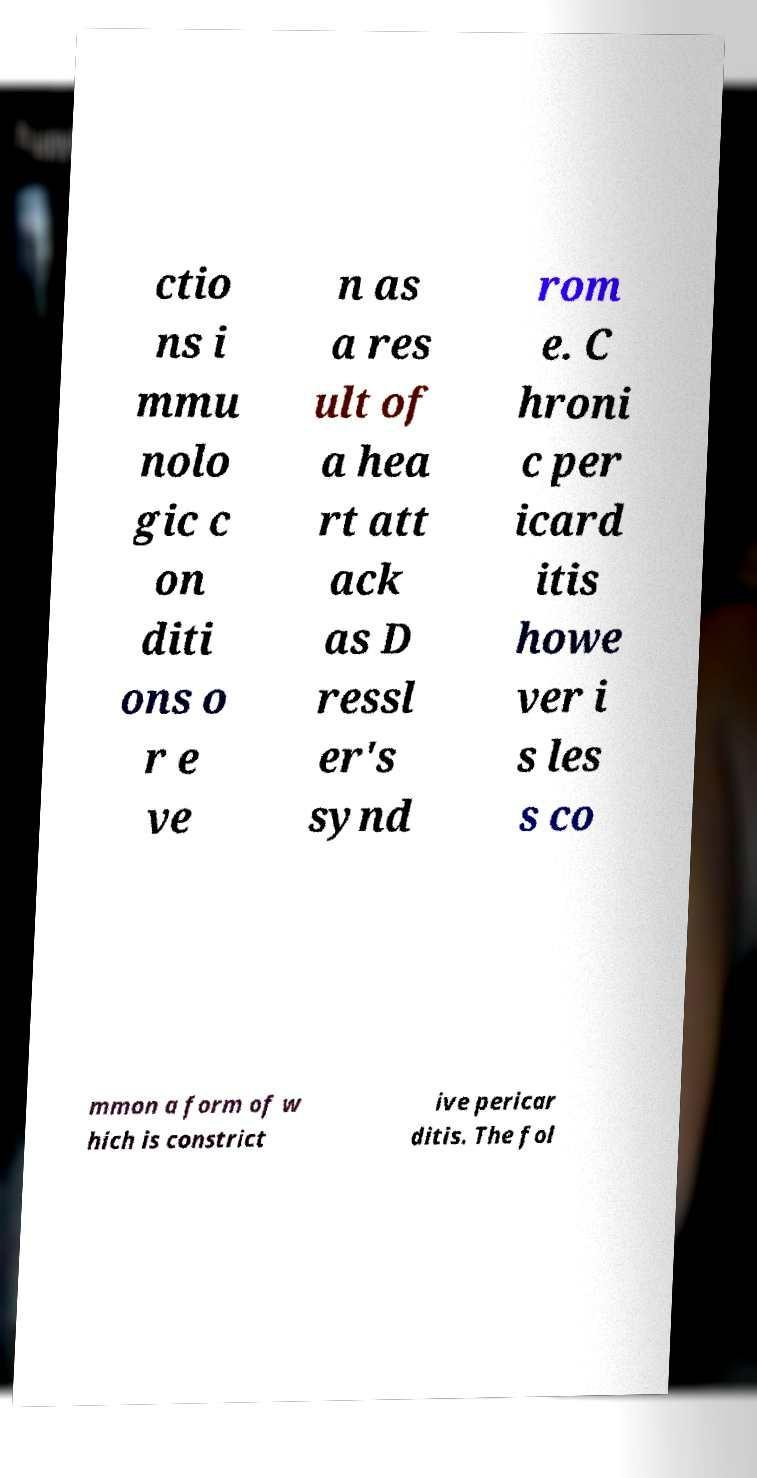Could you assist in decoding the text presented in this image and type it out clearly? ctio ns i mmu nolo gic c on diti ons o r e ve n as a res ult of a hea rt att ack as D ressl er's synd rom e. C hroni c per icard itis howe ver i s les s co mmon a form of w hich is constrict ive pericar ditis. The fol 